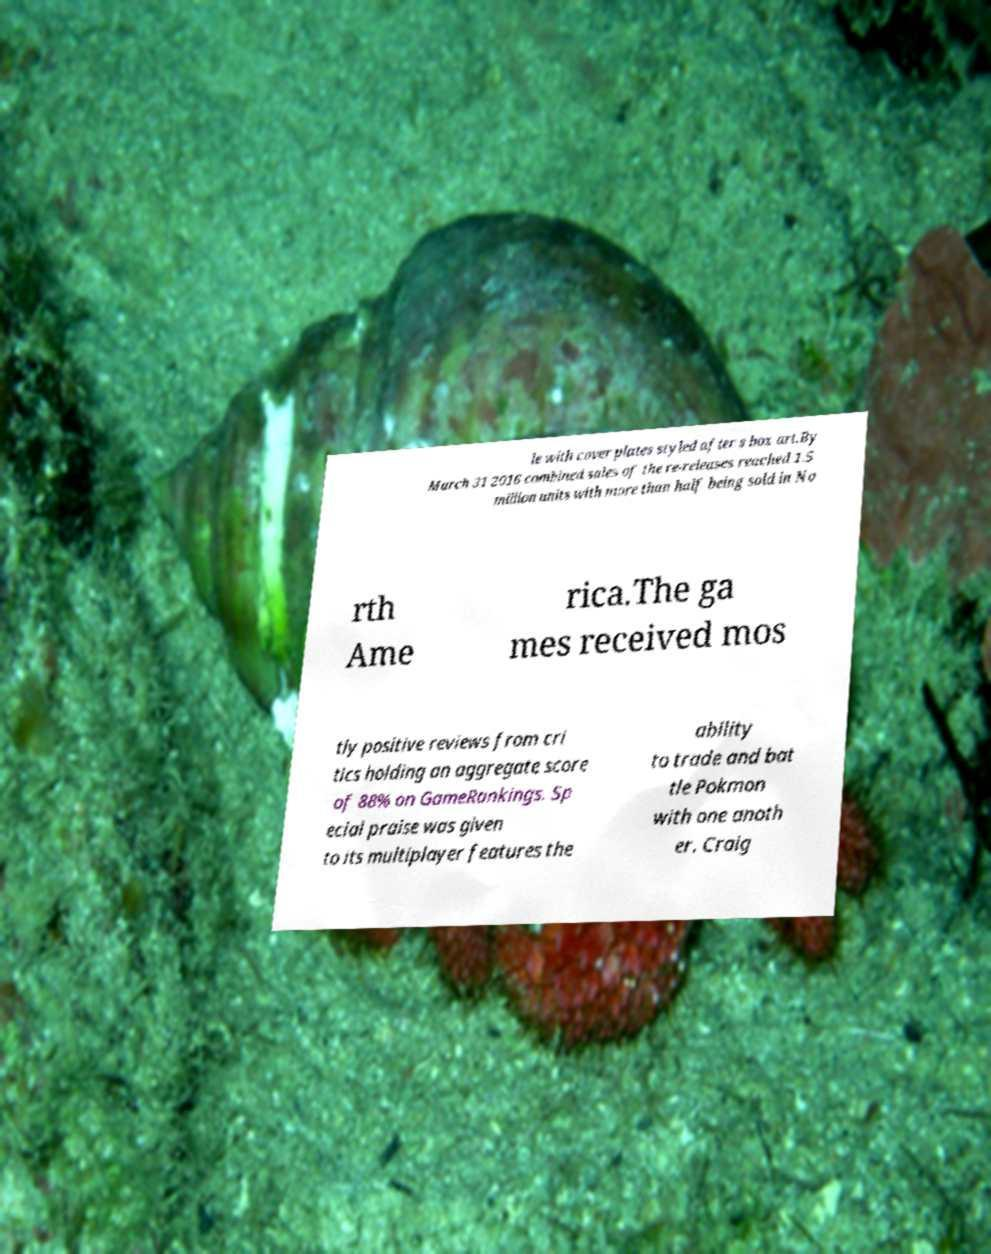Could you extract and type out the text from this image? le with cover plates styled after s box art.By March 31 2016 combined sales of the re-releases reached 1.5 million units with more than half being sold in No rth Ame rica.The ga mes received mos tly positive reviews from cri tics holding an aggregate score of 88% on GameRankings. Sp ecial praise was given to its multiplayer features the ability to trade and bat tle Pokmon with one anoth er. Craig 